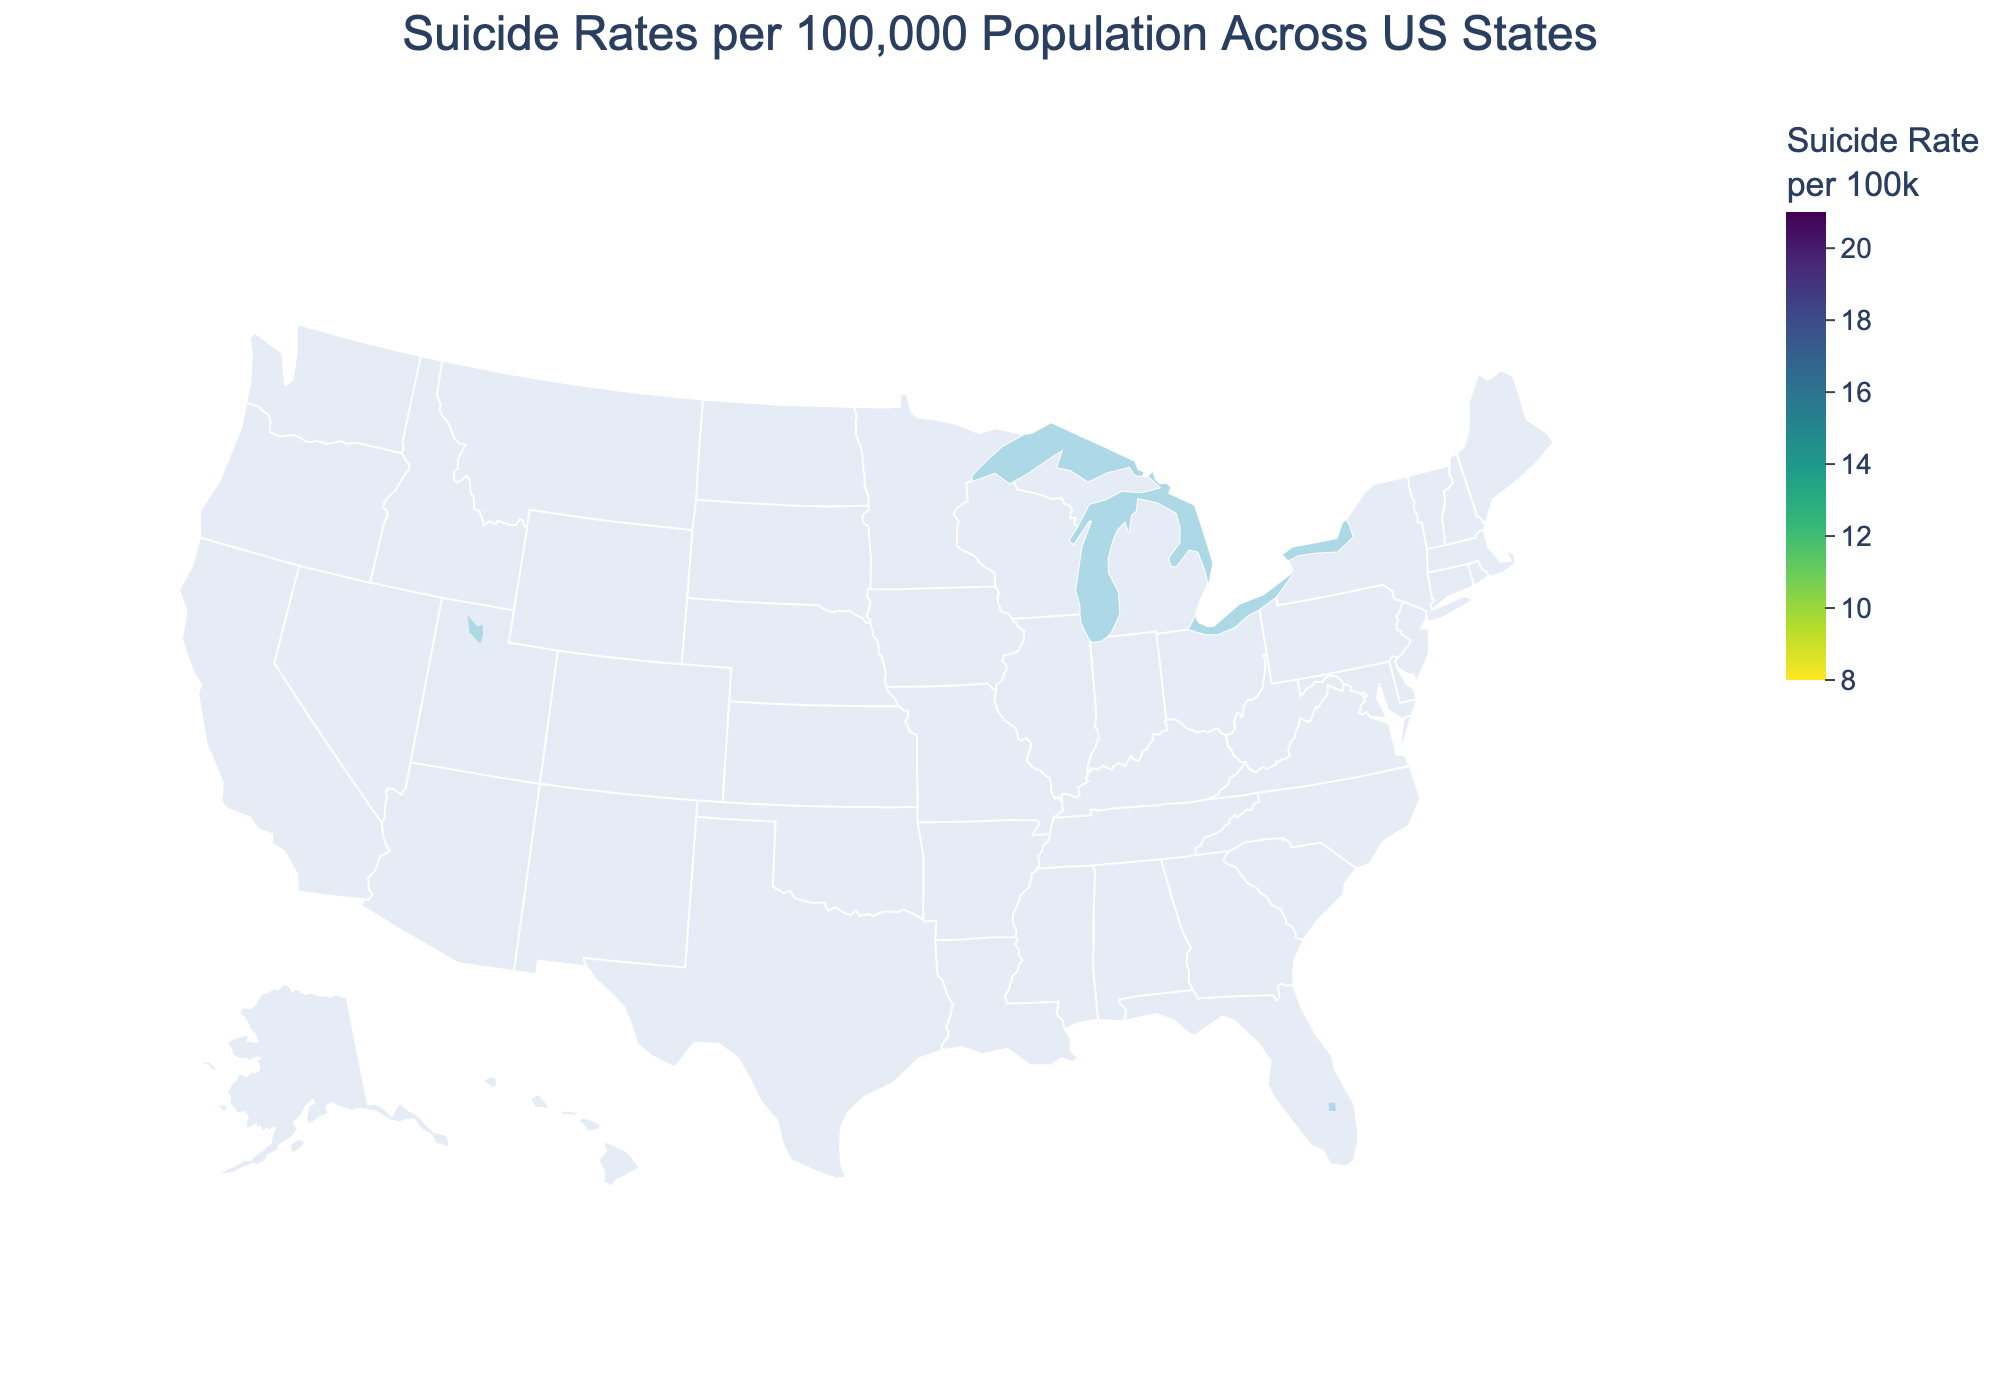What is the title of the map? The title of the map is usually prominently displayed at the top of the plot. It summarizes the main focus of the data being visualized. Here, the title is "Suicide Rates per 100,000 Population Across US States".
Answer: Suicide Rates per 100,000 Population Across US States Which state has the highest suicide rate? To find the state with the highest suicide rate, look for the state with the darkest color shade in the choropleth map. Here, Colorado stands out with a suicide rate of 20.4 per 100,000.
Answer: Colorado How many states have a suicide rate above 15 per 100,000? To determine this, count the states where the suicide rate value is above 15. The states meeting this criterion are Washington, Arizona, Missouri, Tennessee, South Carolina, Alabama, Kentucky, and Colorado. Therefore, there are eight states.
Answer: 8 Which state has the lowest suicide rate? Identify the state with the lightest color shade on the map to find the lowest rate. New York has the lowest suicide rate, with a value of 8.3 per 100,000.
Answer: New York What is the average suicide rate for the states listed? First, sum up all the suicide rates provided, which equals 309.7. Then, divide by the number of states, which is 24. 309.7 / 24 = 12.9.
Answer: 12.9 Compare the suicide rates of California and Colorado. Which state has a higher rate, and by how much? To compare, subtract California’s suicide rate (10.5) from Colorado’s rate (20.4). The difference is 20.4 - 10.5 = 9.9, with Colorado having the higher rate.
Answer: Colorado, by 9.9 Are there any states with approximately the same suicide rate? Look for states with very close or identical suicide rates. Florida and Wisconsin both have a rate of 14.5 per 100,000.
Answer: Florida and Wisconsin Which state in the Northeastern region has the highest suicide rate? Only consider states that are part of the Northeastern US. Among the listed states, Pennsylvania has the highest suicide rate of 14.8 per 100,000 in this region.
Answer: Pennsylvania Are there more states with suicide rates below or above the national average of 13.0 per 100,000? Compare each state’s rate to 13.0. There are 11 states below the average (California, New York, Illinois, Massachusetts, Maryland, Minnesota, Virginia, Georgia, Texas, North Carolina, and South Carolina) and 13 states above it. Thus, there are more states with rates above the national average.
Answer: Above What is the range of the suicide rates among all the states? To find the range, subtract the lowest suicide rate (New York, 8.3) from the highest (Colorado, 20.4). 20.4 - 8.3 = 12.1.
Answer: 12.1 